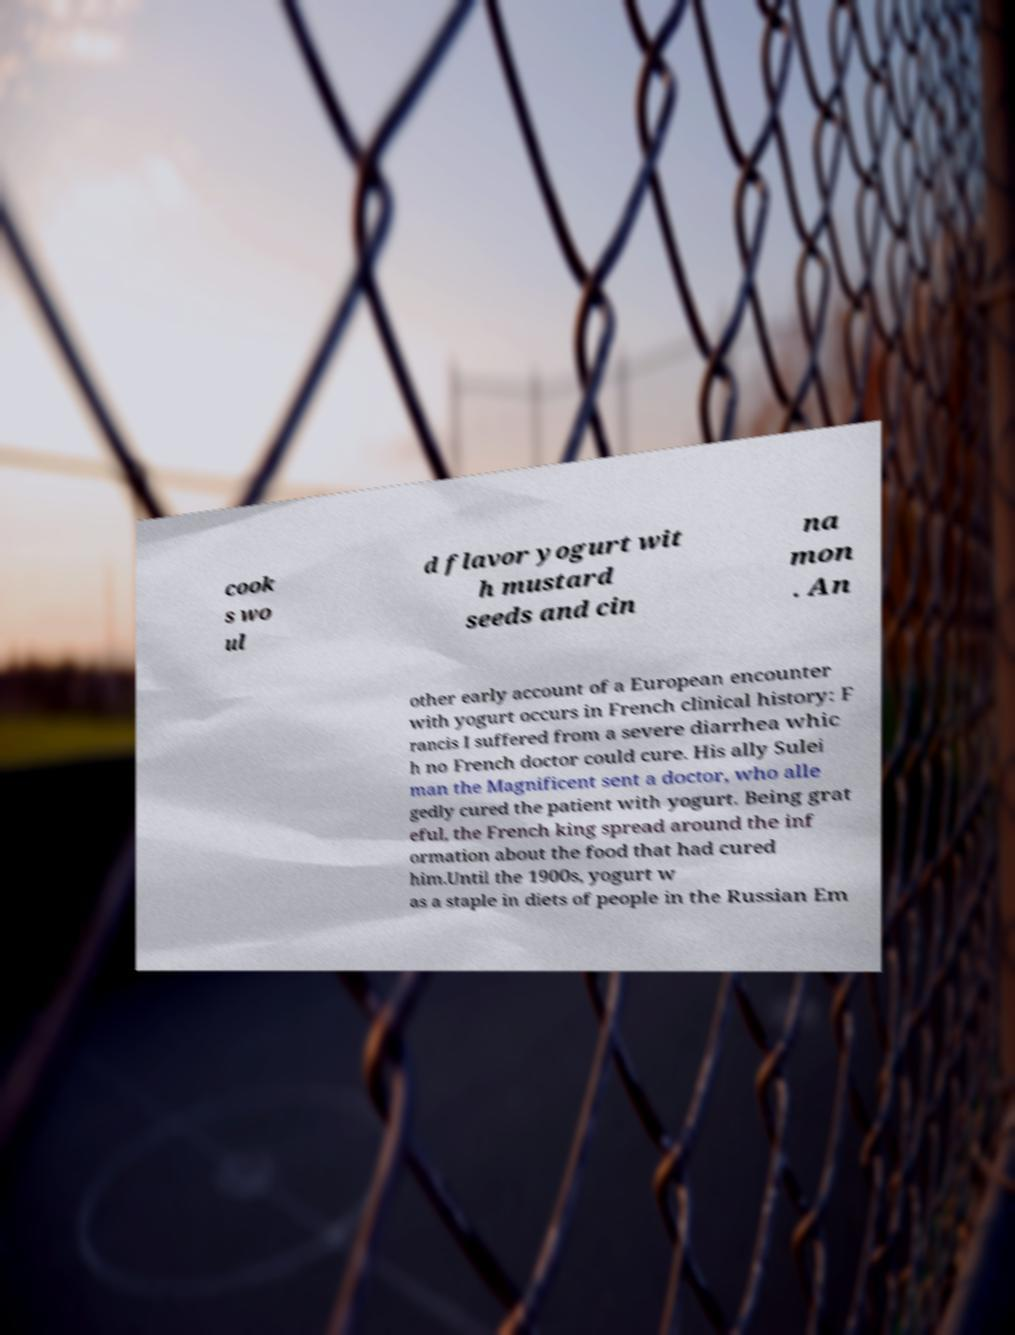Could you assist in decoding the text presented in this image and type it out clearly? cook s wo ul d flavor yogurt wit h mustard seeds and cin na mon . An other early account of a European encounter with yogurt occurs in French clinical history: F rancis I suffered from a severe diarrhea whic h no French doctor could cure. His ally Sulei man the Magnificent sent a doctor, who alle gedly cured the patient with yogurt. Being grat eful, the French king spread around the inf ormation about the food that had cured him.Until the 1900s, yogurt w as a staple in diets of people in the Russian Em 